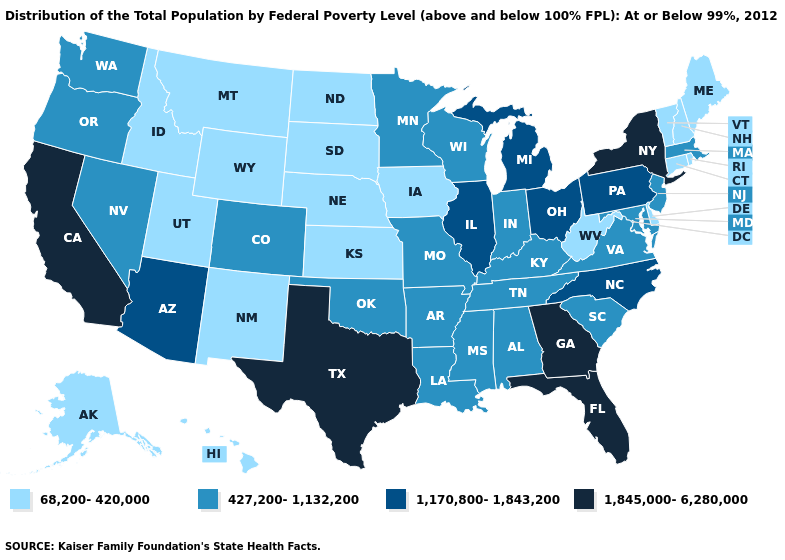Does the map have missing data?
Answer briefly. No. Name the states that have a value in the range 1,170,800-1,843,200?
Write a very short answer. Arizona, Illinois, Michigan, North Carolina, Ohio, Pennsylvania. Which states hav the highest value in the South?
Be succinct. Florida, Georgia, Texas. What is the value of Pennsylvania?
Answer briefly. 1,170,800-1,843,200. What is the lowest value in the Northeast?
Answer briefly. 68,200-420,000. Among the states that border Pennsylvania , does West Virginia have the lowest value?
Give a very brief answer. Yes. What is the value of Delaware?
Concise answer only. 68,200-420,000. How many symbols are there in the legend?
Short answer required. 4. Which states have the lowest value in the West?
Keep it brief. Alaska, Hawaii, Idaho, Montana, New Mexico, Utah, Wyoming. What is the value of Arizona?
Short answer required. 1,170,800-1,843,200. Which states have the lowest value in the Northeast?
Answer briefly. Connecticut, Maine, New Hampshire, Rhode Island, Vermont. Name the states that have a value in the range 1,170,800-1,843,200?
Be succinct. Arizona, Illinois, Michigan, North Carolina, Ohio, Pennsylvania. Is the legend a continuous bar?
Quick response, please. No. What is the value of Colorado?
Keep it brief. 427,200-1,132,200. 